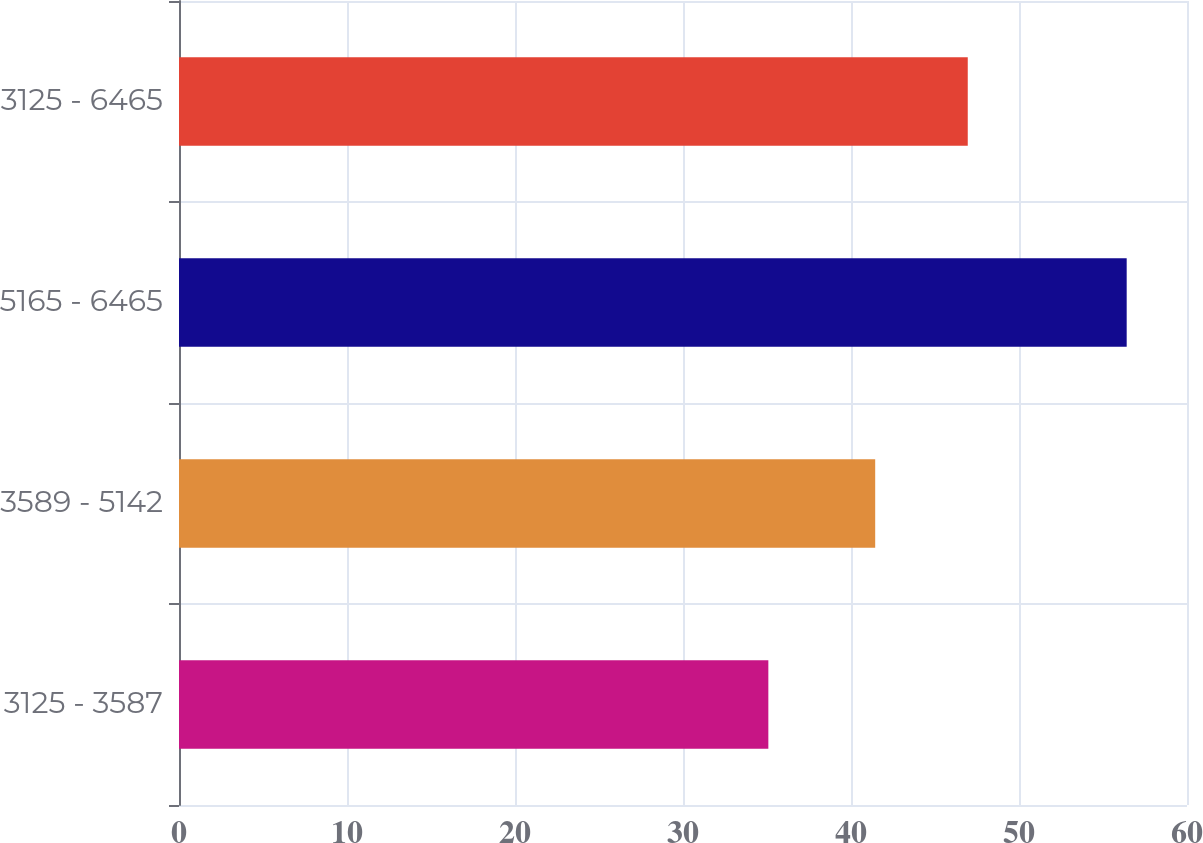Convert chart to OTSL. <chart><loc_0><loc_0><loc_500><loc_500><bar_chart><fcel>3125 - 3587<fcel>3589 - 5142<fcel>5165 - 6465<fcel>3125 - 6465<nl><fcel>35.08<fcel>41.44<fcel>56.41<fcel>46.95<nl></chart> 